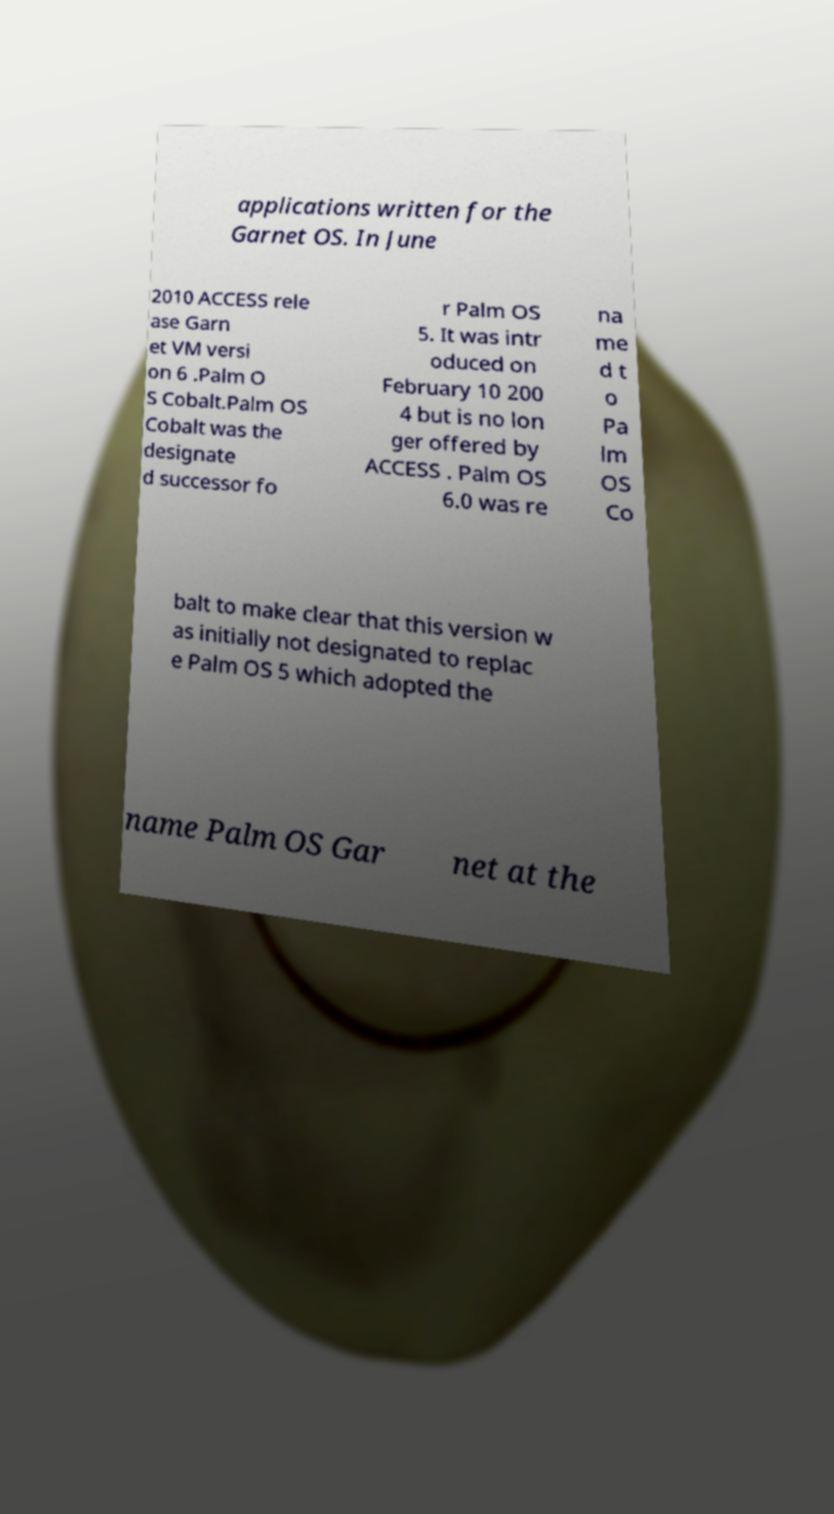For documentation purposes, I need the text within this image transcribed. Could you provide that? applications written for the Garnet OS. In June 2010 ACCESS rele ase Garn et VM versi on 6 .Palm O S Cobalt.Palm OS Cobalt was the designate d successor fo r Palm OS 5. It was intr oduced on February 10 200 4 but is no lon ger offered by ACCESS . Palm OS 6.0 was re na me d t o Pa lm OS Co balt to make clear that this version w as initially not designated to replac e Palm OS 5 which adopted the name Palm OS Gar net at the 